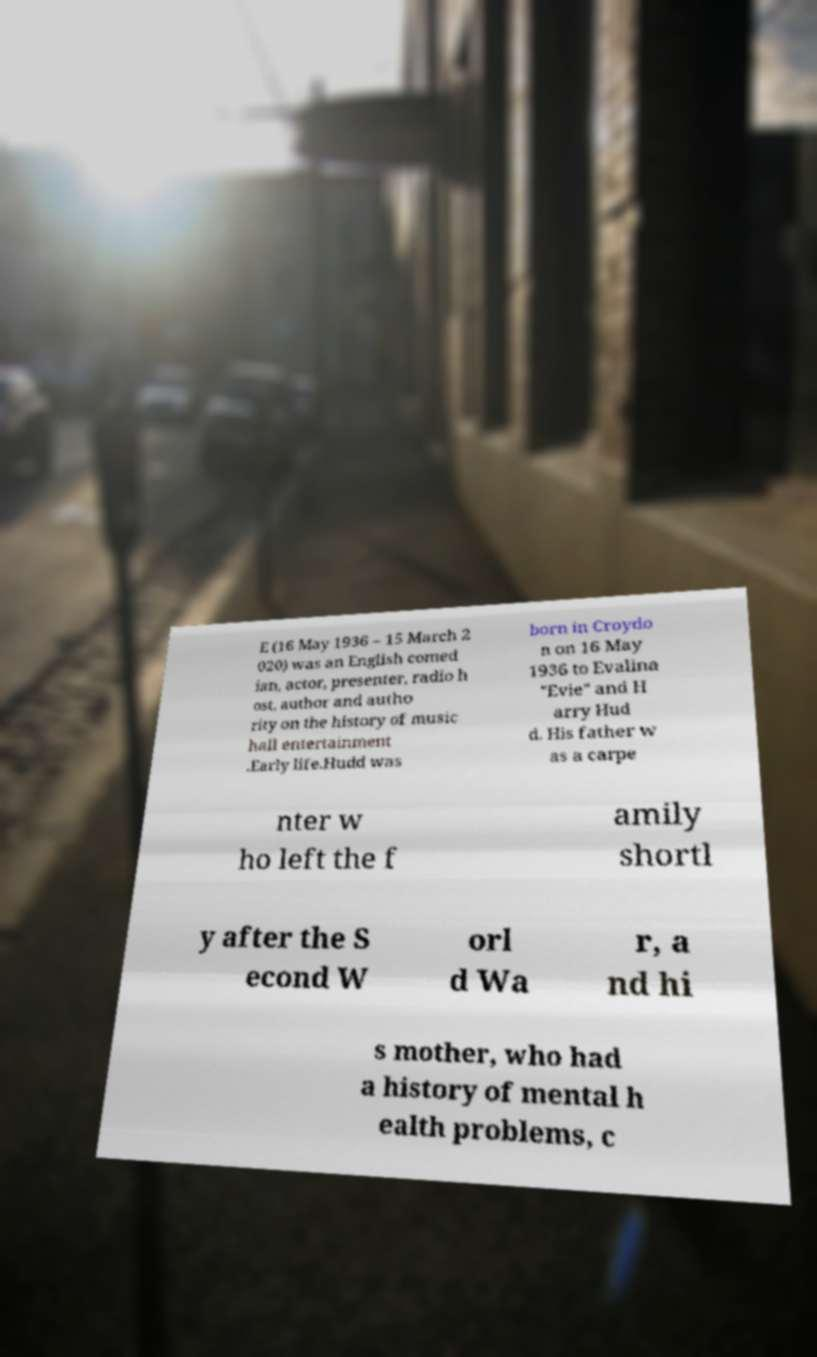Can you read and provide the text displayed in the image?This photo seems to have some interesting text. Can you extract and type it out for me? E (16 May 1936 – 15 March 2 020) was an English comed ian, actor, presenter, radio h ost, author and autho rity on the history of music hall entertainment .Early life.Hudd was born in Croydo n on 16 May 1936 to Evalina "Evie" and H arry Hud d. His father w as a carpe nter w ho left the f amily shortl y after the S econd W orl d Wa r, a nd hi s mother, who had a history of mental h ealth problems, c 